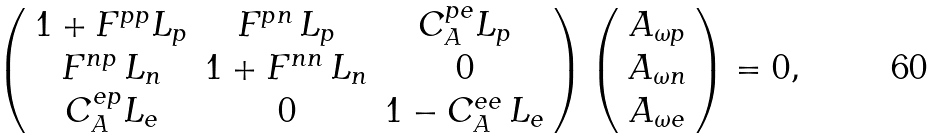<formula> <loc_0><loc_0><loc_500><loc_500>\left ( \begin{array} { c c c } 1 + F ^ { p p } L _ { p } & F ^ { p n } \, L _ { p } & C _ { A } ^ { p e } L _ { p } \\ F ^ { n p } \, L _ { n } & 1 + F ^ { n n } \, L _ { n } & 0 \\ C _ { A } ^ { e p } L _ { e } & 0 & 1 - C _ { A } ^ { e e } \, L _ { e } \end{array} \right ) \left ( \begin{array} { c } A _ { \omega p } \\ A _ { \omega n } \\ A _ { \omega e } \end{array} \right ) = 0 ,</formula> 